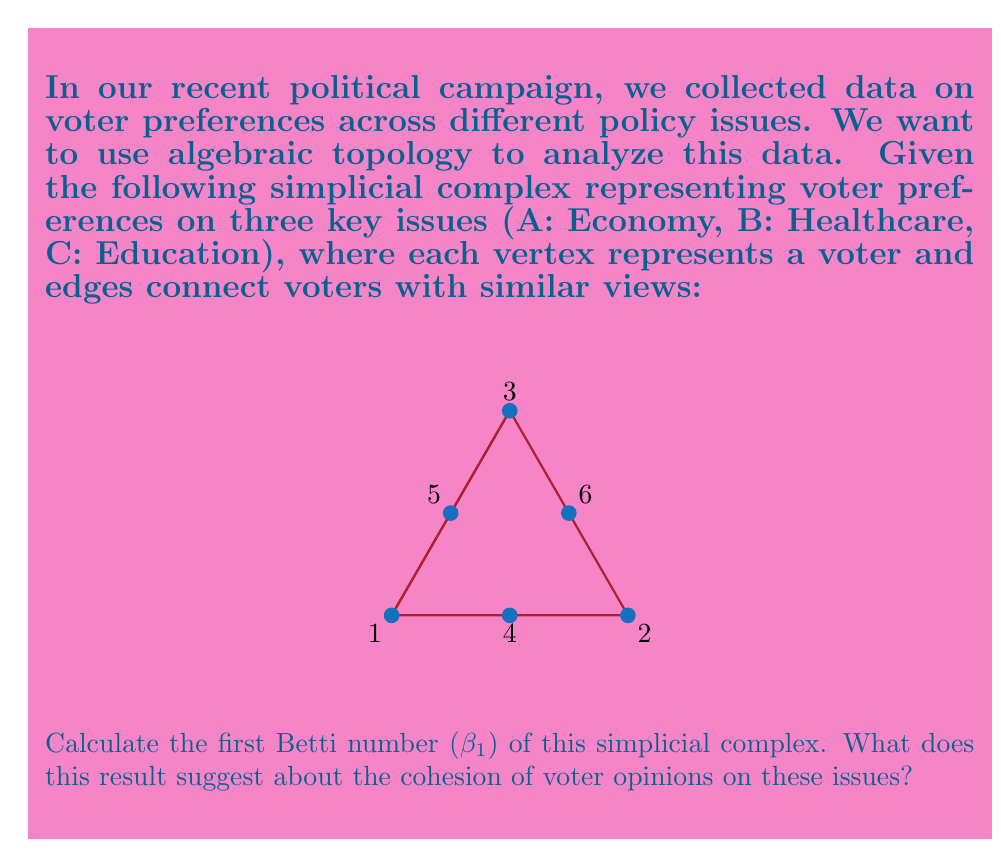Could you help me with this problem? To calculate the first Betti number and interpret its meaning, let's follow these steps:

1) First, we need to count the number of simplices in each dimension:
   - 0-simplices (vertices): 6
   - 1-simplices (edges): 7
   - 2-simplices (triangles): 2

2) Now, let's calculate the Euler characteristic ($\chi$):
   $$\chi = V - E + F$$
   where V is the number of vertices, E is the number of edges, and F is the number of faces.
   $$\chi = 6 - 7 + 2 = 1$$

3) The Betti numbers are related to the Euler characteristic by the formula:
   $$\chi = \beta_0 - \beta_1 + \beta_2$$
   where $\beta_0$ is the number of connected components, $\beta_1$ is the number of 1-dimensional holes, and $\beta_2$ is the number of 2-dimensional voids.

4) We can see that the complex is connected, so $\beta_0 = 1$. There are no voids, so $\beta_2 = 0$.

5) Substituting into the formula:
   $$1 = 1 - \beta_1 + 0$$

6) Solving for $\beta_1$:
   $$\beta_1 = 1 - 1 + 0 = 0$$

Interpretation: The first Betti number ($\beta_1$) being 0 suggests that there are no 1-dimensional holes in the simplicial complex. In the context of voter preferences, this indicates a high level of cohesion in voter opinions across the three key issues. There are no significant gaps or contradictions in the voters' views, suggesting a relatively unified stance on the interconnected issues of economy, healthcare, and education.
Answer: $\beta_1 = 0$, indicating high cohesion in voter opinions. 